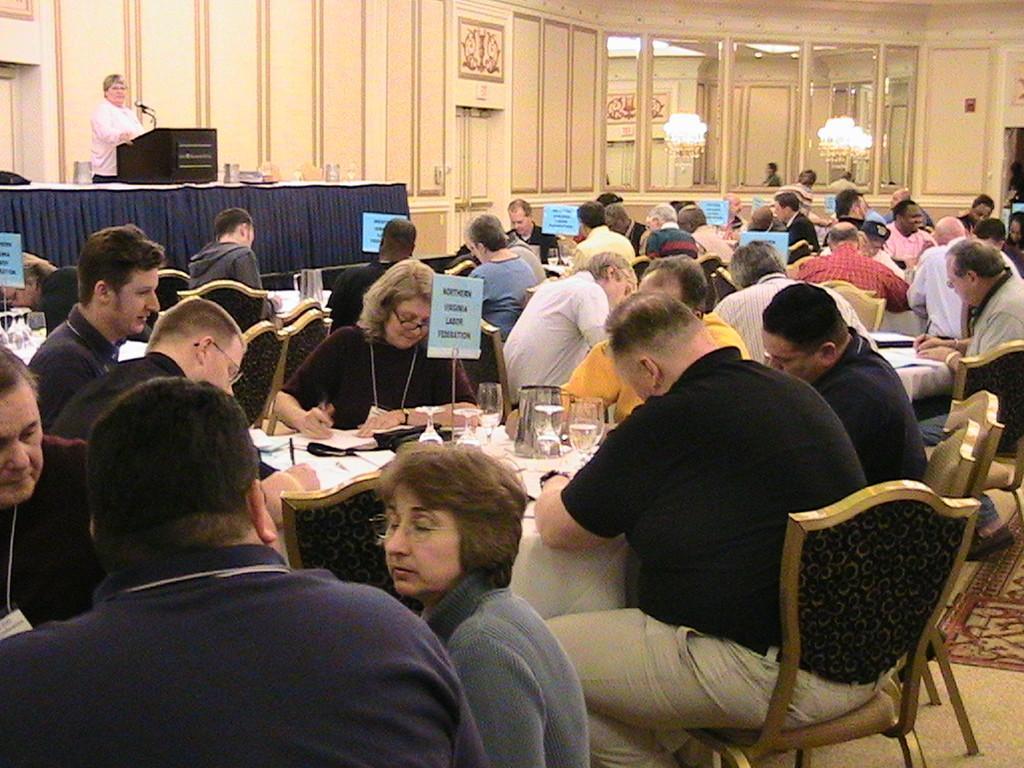Could you give a brief overview of what you see in this image? In this image I see number of people who are sitting on chairs and there are tables in front of them on which there are glasses, jars and boards, I can also see there is a woman who is in front of a podium and she is standing and I can also see the mic. In the background I see the wall, mirrors and the lights. 